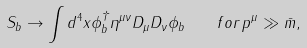<formula> <loc_0><loc_0><loc_500><loc_500>S _ { b } \rightarrow \int d ^ { 4 } x \phi _ { b } ^ { \dagger } \eta ^ { \mu \nu } D _ { \mu } D _ { \nu } \phi _ { b } \quad f o r \, p ^ { \mu } \gg \bar { m } ,</formula> 